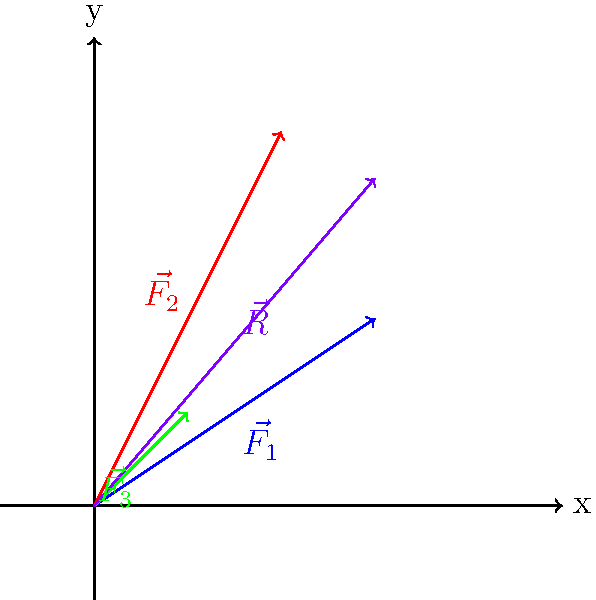In a study of ocean currents affecting plastic debris, three force vectors represent different currents: $\vec{F_1} = 3\hat{i} + 2\hat{j}$, $\vec{F_2} = 2\hat{i} + 4\hat{j}$, and $\vec{F_3} = \hat{i} + \hat{j}$ (all in Newtons). Calculate the magnitude of the resultant force vector $\vec{R}$ acting on the plastic debris. To find the magnitude of the resultant force vector, we'll follow these steps:

1) First, we need to find the resultant vector $\vec{R}$ by adding the three force vectors:
   $\vec{R} = \vec{F_1} + \vec{F_2} + \vec{F_3}$

2) Add the x-components:
   $R_x = 3 + 2 + 1 = 6$ N

3) Add the y-components:
   $R_y = 2 + 4 + 1 = 7$ N

4) The resultant vector is:
   $\vec{R} = 6\hat{i} + 7\hat{j}$ N

5) To find the magnitude of $\vec{R}$, we use the Pythagorean theorem:
   $|\vec{R}| = \sqrt{R_x^2 + R_y^2}$

6) Substitute the values:
   $|\vec{R}| = \sqrt{6^2 + 7^2}$

7) Calculate:
   $|\vec{R}| = \sqrt{36 + 49} = \sqrt{85} \approx 9.22$ N

Therefore, the magnitude of the resultant force vector is approximately 9.22 N.
Answer: $9.22$ N 